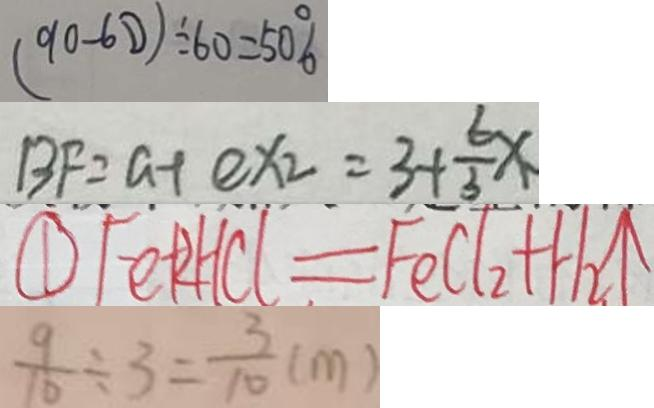Convert formula to latex. <formula><loc_0><loc_0><loc_500><loc_500>( 9 0 - 6 0 ) \div 6 0 = 5 0 \% 
 B F = a + e x _ { 2 } = 3 + \frac { 6 } { 3 } x 
 \textcircled { 1 } F e + 2 H C l = F e C l _ { 2 } + H _ { 2 } \uparrow 
 \frac { 9 } { 1 0 } \div 3 = \frac { 3 } { 1 0 } ( m )</formula> 